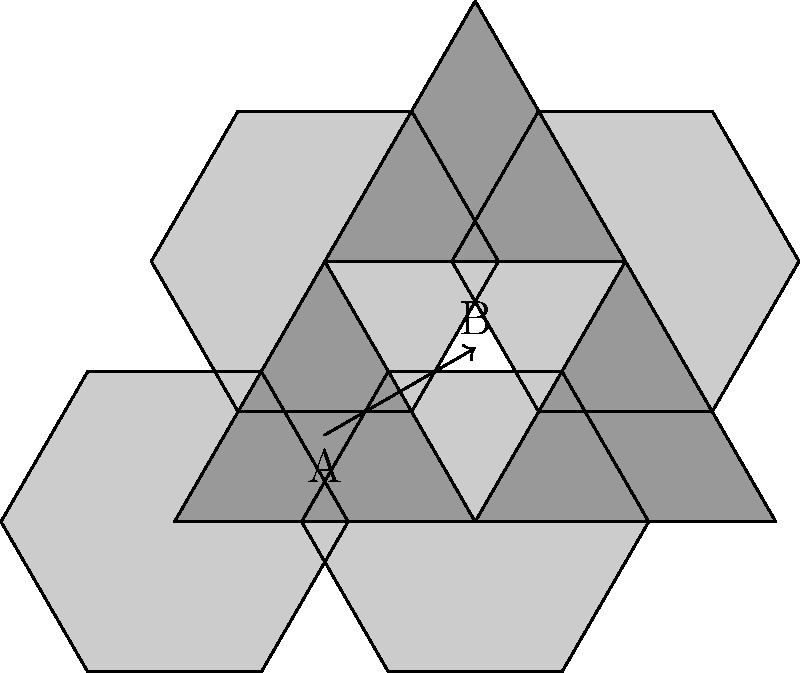A retail store is considering using a tessellation of regular hexagons and equilateral triangles for its floor plan to maximize space utilization. If the side length of each shape is 3 meters, and the store's total floor area is 1000 square meters, approximately how many hexagonal display areas (labeled A in the diagram) can be accommodated? To solve this problem, we'll follow these steps:

1) First, calculate the area of a single hexagon:
   Area of hexagon = $\frac{3\sqrt{3}}{2}s^2$, where $s$ is the side length
   Area = $\frac{3\sqrt{3}}{2}(3^2) = \frac{27\sqrt{3}}{2} \approx 23.38$ m²

2) Calculate the area of a single triangle:
   Area of triangle = $\frac{\sqrt{3}}{4}s^2$
   Area = $\frac{\sqrt{3}}{4}(3^2) = \frac{9\sqrt{3}}{4} \approx 3.90$ m²

3) Observe the ratio of hexagons to triangles in the tessellation:
   For every 4 hexagons, there are 3 triangles.

4) Calculate the total area covered by one set of 4 hexagons and 3 triangles:
   Total area = $4(23.38) + 3(3.90) = 93.52 + 11.70 = 105.22$ m²

5) Calculate how many of these sets fit in the total floor area:
   Number of sets = $1000 \text{ m²} / 105.22 \text{ m²} \approx 9.50$

6) Calculate the number of hexagons:
   Number of hexagons = $9.50 * 4 = 38$

Therefore, approximately 38 hexagonal display areas can be accommodated.
Answer: 38 hexagonal display areas 